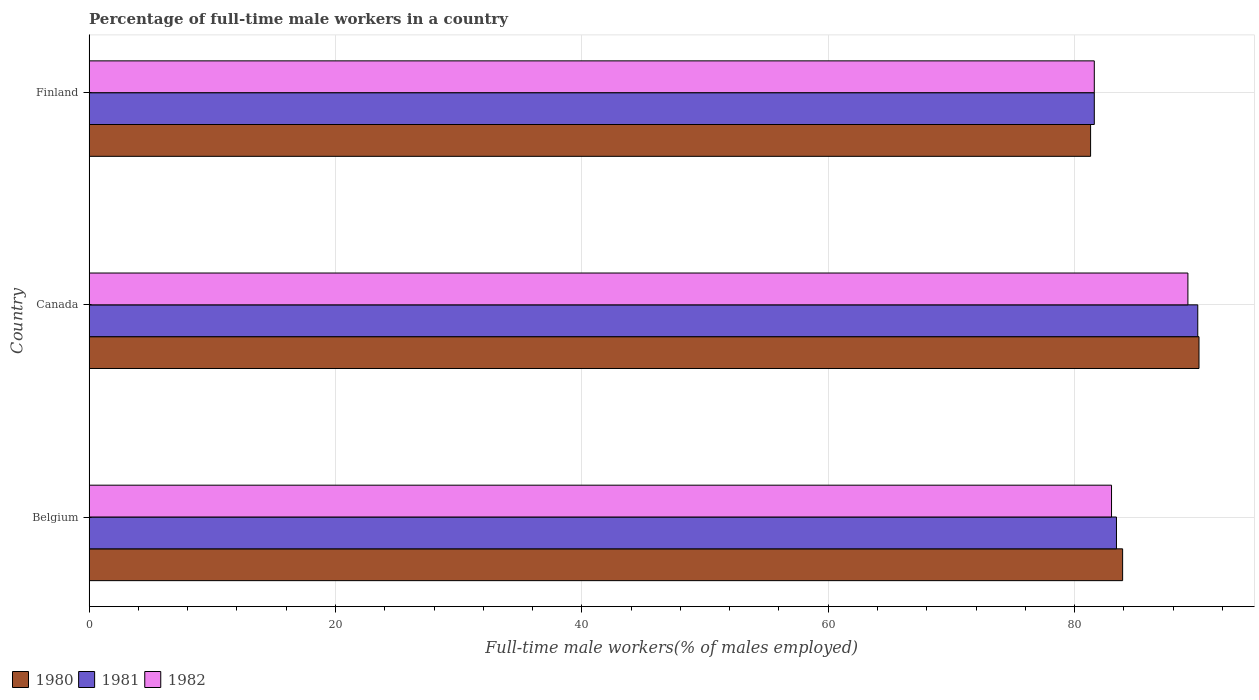How many groups of bars are there?
Keep it short and to the point. 3. Are the number of bars per tick equal to the number of legend labels?
Make the answer very short. Yes. How many bars are there on the 1st tick from the top?
Your answer should be compact. 3. What is the label of the 1st group of bars from the top?
Ensure brevity in your answer.  Finland. In how many cases, is the number of bars for a given country not equal to the number of legend labels?
Ensure brevity in your answer.  0. What is the percentage of full-time male workers in 1980 in Belgium?
Offer a terse response. 83.9. Across all countries, what is the maximum percentage of full-time male workers in 1980?
Make the answer very short. 90.1. Across all countries, what is the minimum percentage of full-time male workers in 1982?
Make the answer very short. 81.6. In which country was the percentage of full-time male workers in 1980 maximum?
Your response must be concise. Canada. In which country was the percentage of full-time male workers in 1980 minimum?
Give a very brief answer. Finland. What is the total percentage of full-time male workers in 1981 in the graph?
Keep it short and to the point. 255. What is the difference between the percentage of full-time male workers in 1982 in Canada and that in Finland?
Make the answer very short. 7.6. What is the difference between the percentage of full-time male workers in 1980 in Canada and the percentage of full-time male workers in 1981 in Belgium?
Your answer should be compact. 6.7. What is the average percentage of full-time male workers in 1980 per country?
Your answer should be compact. 85.1. What is the difference between the percentage of full-time male workers in 1982 and percentage of full-time male workers in 1981 in Belgium?
Keep it short and to the point. -0.4. What is the ratio of the percentage of full-time male workers in 1980 in Belgium to that in Canada?
Keep it short and to the point. 0.93. What is the difference between the highest and the second highest percentage of full-time male workers in 1981?
Offer a terse response. 6.6. What is the difference between the highest and the lowest percentage of full-time male workers in 1982?
Ensure brevity in your answer.  7.6. What does the 1st bar from the top in Finland represents?
Give a very brief answer. 1982. What does the 3rd bar from the bottom in Finland represents?
Offer a terse response. 1982. Is it the case that in every country, the sum of the percentage of full-time male workers in 1981 and percentage of full-time male workers in 1980 is greater than the percentage of full-time male workers in 1982?
Give a very brief answer. Yes. How many bars are there?
Keep it short and to the point. 9. How many countries are there in the graph?
Keep it short and to the point. 3. What is the difference between two consecutive major ticks on the X-axis?
Make the answer very short. 20. Does the graph contain any zero values?
Keep it short and to the point. No. Does the graph contain grids?
Provide a succinct answer. Yes. Where does the legend appear in the graph?
Provide a short and direct response. Bottom left. How many legend labels are there?
Ensure brevity in your answer.  3. How are the legend labels stacked?
Offer a very short reply. Horizontal. What is the title of the graph?
Provide a succinct answer. Percentage of full-time male workers in a country. What is the label or title of the X-axis?
Offer a terse response. Full-time male workers(% of males employed). What is the label or title of the Y-axis?
Your answer should be compact. Country. What is the Full-time male workers(% of males employed) in 1980 in Belgium?
Make the answer very short. 83.9. What is the Full-time male workers(% of males employed) in 1981 in Belgium?
Provide a succinct answer. 83.4. What is the Full-time male workers(% of males employed) of 1982 in Belgium?
Offer a very short reply. 83. What is the Full-time male workers(% of males employed) of 1980 in Canada?
Provide a short and direct response. 90.1. What is the Full-time male workers(% of males employed) of 1981 in Canada?
Your response must be concise. 90. What is the Full-time male workers(% of males employed) in 1982 in Canada?
Offer a very short reply. 89.2. What is the Full-time male workers(% of males employed) in 1980 in Finland?
Keep it short and to the point. 81.3. What is the Full-time male workers(% of males employed) in 1981 in Finland?
Ensure brevity in your answer.  81.6. What is the Full-time male workers(% of males employed) of 1982 in Finland?
Offer a terse response. 81.6. Across all countries, what is the maximum Full-time male workers(% of males employed) of 1980?
Give a very brief answer. 90.1. Across all countries, what is the maximum Full-time male workers(% of males employed) in 1982?
Make the answer very short. 89.2. Across all countries, what is the minimum Full-time male workers(% of males employed) of 1980?
Ensure brevity in your answer.  81.3. Across all countries, what is the minimum Full-time male workers(% of males employed) in 1981?
Provide a succinct answer. 81.6. Across all countries, what is the minimum Full-time male workers(% of males employed) in 1982?
Provide a short and direct response. 81.6. What is the total Full-time male workers(% of males employed) of 1980 in the graph?
Offer a very short reply. 255.3. What is the total Full-time male workers(% of males employed) of 1981 in the graph?
Offer a terse response. 255. What is the total Full-time male workers(% of males employed) in 1982 in the graph?
Ensure brevity in your answer.  253.8. What is the difference between the Full-time male workers(% of males employed) in 1982 in Belgium and that in Canada?
Your answer should be compact. -6.2. What is the difference between the Full-time male workers(% of males employed) in 1980 in Belgium and that in Finland?
Your answer should be compact. 2.6. What is the difference between the Full-time male workers(% of males employed) in 1982 in Canada and that in Finland?
Make the answer very short. 7.6. What is the difference between the Full-time male workers(% of males employed) in 1980 in Belgium and the Full-time male workers(% of males employed) in 1982 in Canada?
Your answer should be compact. -5.3. What is the difference between the Full-time male workers(% of males employed) in 1980 in Belgium and the Full-time male workers(% of males employed) in 1981 in Finland?
Provide a succinct answer. 2.3. What is the difference between the Full-time male workers(% of males employed) of 1980 in Canada and the Full-time male workers(% of males employed) of 1981 in Finland?
Keep it short and to the point. 8.5. What is the average Full-time male workers(% of males employed) in 1980 per country?
Your answer should be very brief. 85.1. What is the average Full-time male workers(% of males employed) in 1982 per country?
Provide a succinct answer. 84.6. What is the difference between the Full-time male workers(% of males employed) of 1981 and Full-time male workers(% of males employed) of 1982 in Belgium?
Ensure brevity in your answer.  0.4. What is the difference between the Full-time male workers(% of males employed) of 1981 and Full-time male workers(% of males employed) of 1982 in Canada?
Keep it short and to the point. 0.8. What is the difference between the Full-time male workers(% of males employed) in 1980 and Full-time male workers(% of males employed) in 1981 in Finland?
Make the answer very short. -0.3. What is the difference between the Full-time male workers(% of males employed) of 1981 and Full-time male workers(% of males employed) of 1982 in Finland?
Keep it short and to the point. 0. What is the ratio of the Full-time male workers(% of males employed) of 1980 in Belgium to that in Canada?
Keep it short and to the point. 0.93. What is the ratio of the Full-time male workers(% of males employed) of 1981 in Belgium to that in Canada?
Offer a very short reply. 0.93. What is the ratio of the Full-time male workers(% of males employed) of 1982 in Belgium to that in Canada?
Your answer should be compact. 0.93. What is the ratio of the Full-time male workers(% of males employed) of 1980 in Belgium to that in Finland?
Ensure brevity in your answer.  1.03. What is the ratio of the Full-time male workers(% of males employed) of 1981 in Belgium to that in Finland?
Offer a very short reply. 1.02. What is the ratio of the Full-time male workers(% of males employed) of 1982 in Belgium to that in Finland?
Give a very brief answer. 1.02. What is the ratio of the Full-time male workers(% of males employed) of 1980 in Canada to that in Finland?
Your response must be concise. 1.11. What is the ratio of the Full-time male workers(% of males employed) in 1981 in Canada to that in Finland?
Give a very brief answer. 1.1. What is the ratio of the Full-time male workers(% of males employed) of 1982 in Canada to that in Finland?
Offer a very short reply. 1.09. What is the difference between the highest and the second highest Full-time male workers(% of males employed) of 1981?
Your answer should be compact. 6.6. What is the difference between the highest and the second highest Full-time male workers(% of males employed) of 1982?
Give a very brief answer. 6.2. What is the difference between the highest and the lowest Full-time male workers(% of males employed) in 1980?
Provide a short and direct response. 8.8. What is the difference between the highest and the lowest Full-time male workers(% of males employed) in 1982?
Your response must be concise. 7.6. 